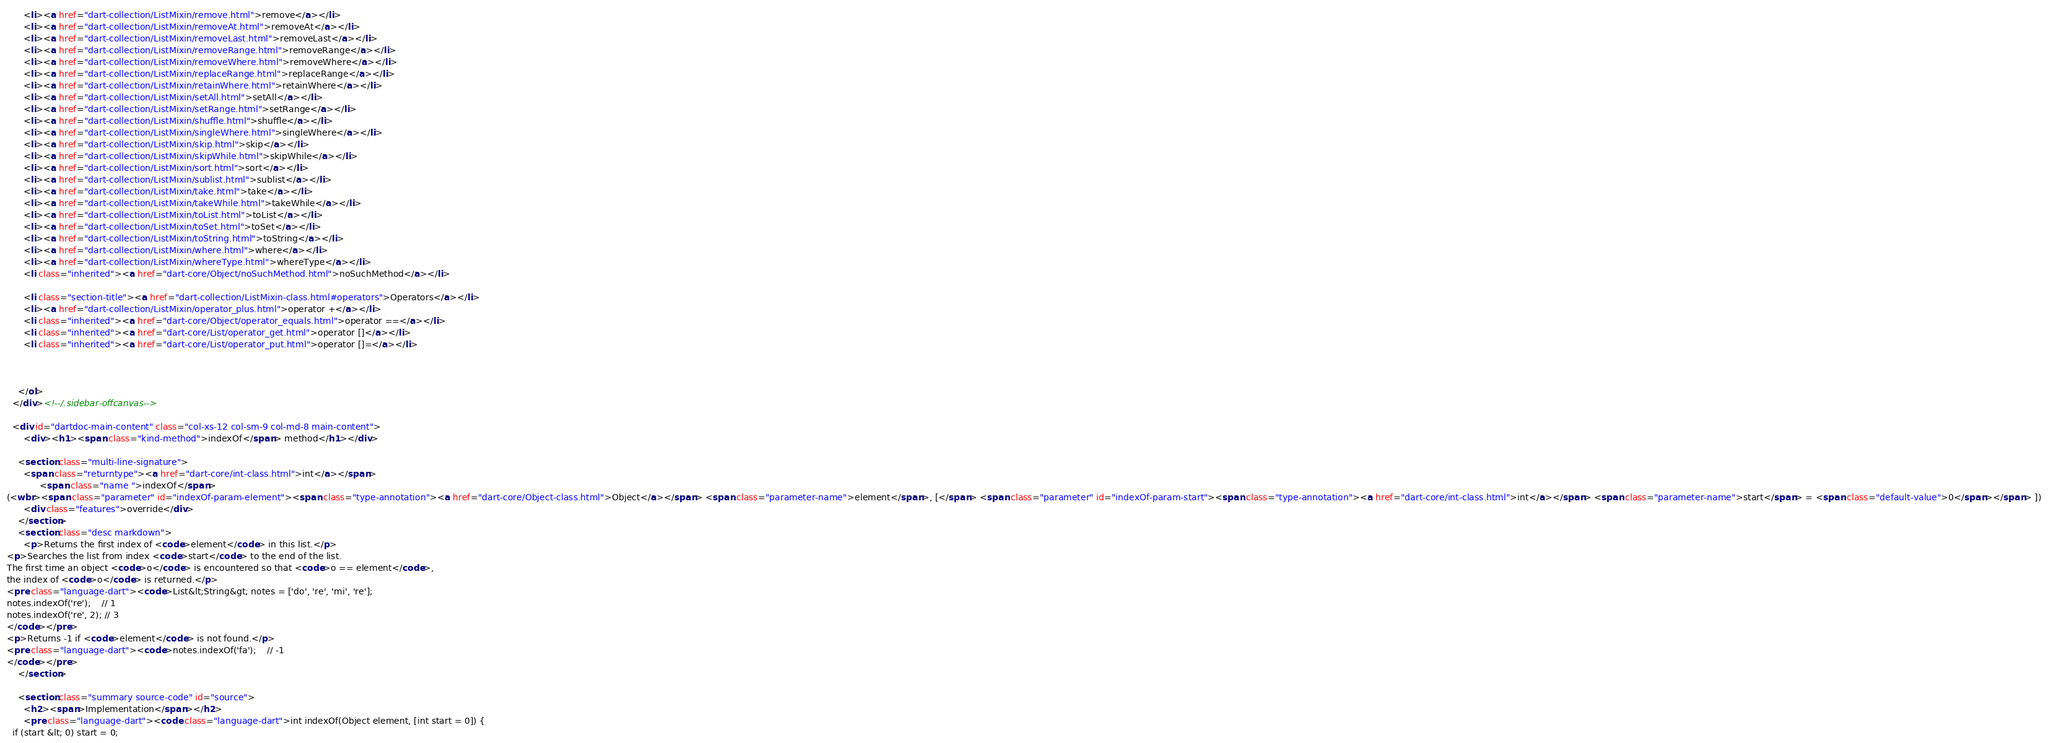<code> <loc_0><loc_0><loc_500><loc_500><_HTML_>      <li><a href="dart-collection/ListMixin/remove.html">remove</a></li>
      <li><a href="dart-collection/ListMixin/removeAt.html">removeAt</a></li>
      <li><a href="dart-collection/ListMixin/removeLast.html">removeLast</a></li>
      <li><a href="dart-collection/ListMixin/removeRange.html">removeRange</a></li>
      <li><a href="dart-collection/ListMixin/removeWhere.html">removeWhere</a></li>
      <li><a href="dart-collection/ListMixin/replaceRange.html">replaceRange</a></li>
      <li><a href="dart-collection/ListMixin/retainWhere.html">retainWhere</a></li>
      <li><a href="dart-collection/ListMixin/setAll.html">setAll</a></li>
      <li><a href="dart-collection/ListMixin/setRange.html">setRange</a></li>
      <li><a href="dart-collection/ListMixin/shuffle.html">shuffle</a></li>
      <li><a href="dart-collection/ListMixin/singleWhere.html">singleWhere</a></li>
      <li><a href="dart-collection/ListMixin/skip.html">skip</a></li>
      <li><a href="dart-collection/ListMixin/skipWhile.html">skipWhile</a></li>
      <li><a href="dart-collection/ListMixin/sort.html">sort</a></li>
      <li><a href="dart-collection/ListMixin/sublist.html">sublist</a></li>
      <li><a href="dart-collection/ListMixin/take.html">take</a></li>
      <li><a href="dart-collection/ListMixin/takeWhile.html">takeWhile</a></li>
      <li><a href="dart-collection/ListMixin/toList.html">toList</a></li>
      <li><a href="dart-collection/ListMixin/toSet.html">toSet</a></li>
      <li><a href="dart-collection/ListMixin/toString.html">toString</a></li>
      <li><a href="dart-collection/ListMixin/where.html">where</a></li>
      <li><a href="dart-collection/ListMixin/whereType.html">whereType</a></li>
      <li class="inherited"><a href="dart-core/Object/noSuchMethod.html">noSuchMethod</a></li>
    
      <li class="section-title"><a href="dart-collection/ListMixin-class.html#operators">Operators</a></li>
      <li><a href="dart-collection/ListMixin/operator_plus.html">operator +</a></li>
      <li class="inherited"><a href="dart-core/Object/operator_equals.html">operator ==</a></li>
      <li class="inherited"><a href="dart-core/List/operator_get.html">operator []</a></li>
      <li class="inherited"><a href="dart-core/List/operator_put.html">operator []=</a></li>
    
    
    
    </ol>
  </div><!--/.sidebar-offcanvas-->

  <div id="dartdoc-main-content" class="col-xs-12 col-sm-9 col-md-8 main-content">
      <div><h1><span class="kind-method">indexOf</span> method</h1></div>

    <section class="multi-line-signature">
      <span class="returntype"><a href="dart-core/int-class.html">int</a></span>
            <span class="name ">indexOf</span>
(<wbr><span class="parameter" id="indexOf-param-element"><span class="type-annotation"><a href="dart-core/Object-class.html">Object</a></span> <span class="parameter-name">element</span>, [</span> <span class="parameter" id="indexOf-param-start"><span class="type-annotation"><a href="dart-core/int-class.html">int</a></span> <span class="parameter-name">start</span> = <span class="default-value">0</span></span> ])
      <div class="features">override</div>
    </section>
    <section class="desc markdown">
      <p>Returns the first index of <code>element</code> in this list.</p>
<p>Searches the list from index <code>start</code> to the end of the list.
The first time an object <code>o</code> is encountered so that <code>o == element</code>,
the index of <code>o</code> is returned.</p>
<pre class="language-dart"><code>List&lt;String&gt; notes = ['do', 're', 'mi', 're'];
notes.indexOf('re');    // 1
notes.indexOf('re', 2); // 3
</code></pre>
<p>Returns -1 if <code>element</code> is not found.</p>
<pre class="language-dart"><code>notes.indexOf('fa');    // -1
</code></pre>
    </section>
    
    <section class="summary source-code" id="source">
      <h2><span>Implementation</span></h2>
      <pre class="language-dart"><code class="language-dart">int indexOf(Object element, [int start = 0]) {
  if (start &lt; 0) start = 0;</code> 